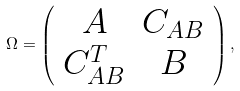Convert formula to latex. <formula><loc_0><loc_0><loc_500><loc_500>\Omega = \left ( \begin{array} { c c } A & C _ { A B } \\ C _ { A B } ^ { T } & B \\ \end{array} \right ) ,</formula> 